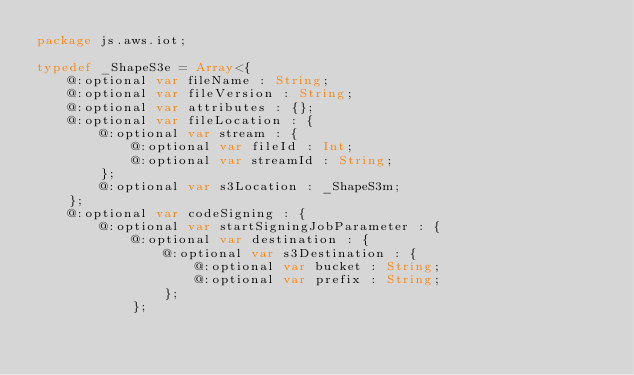<code> <loc_0><loc_0><loc_500><loc_500><_Haxe_>package js.aws.iot;

typedef _ShapeS3e = Array<{
    @:optional var fileName : String;
    @:optional var fileVersion : String;
    @:optional var attributes : {};
    @:optional var fileLocation : {
        @:optional var stream : {
            @:optional var fileId : Int;
            @:optional var streamId : String;
        };
        @:optional var s3Location : _ShapeS3m;
    };
    @:optional var codeSigning : {
        @:optional var startSigningJobParameter : {
            @:optional var destination : {
                @:optional var s3Destination : {
                    @:optional var bucket : String;
                    @:optional var prefix : String;
                };
            };</code> 